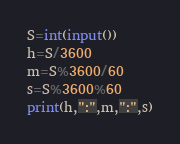Convert code to text. <code><loc_0><loc_0><loc_500><loc_500><_Python_>S=int(input())
h=S/3600
m=S%3600/60
s=S%3600%60
print(h,":",m,":",s)</code> 